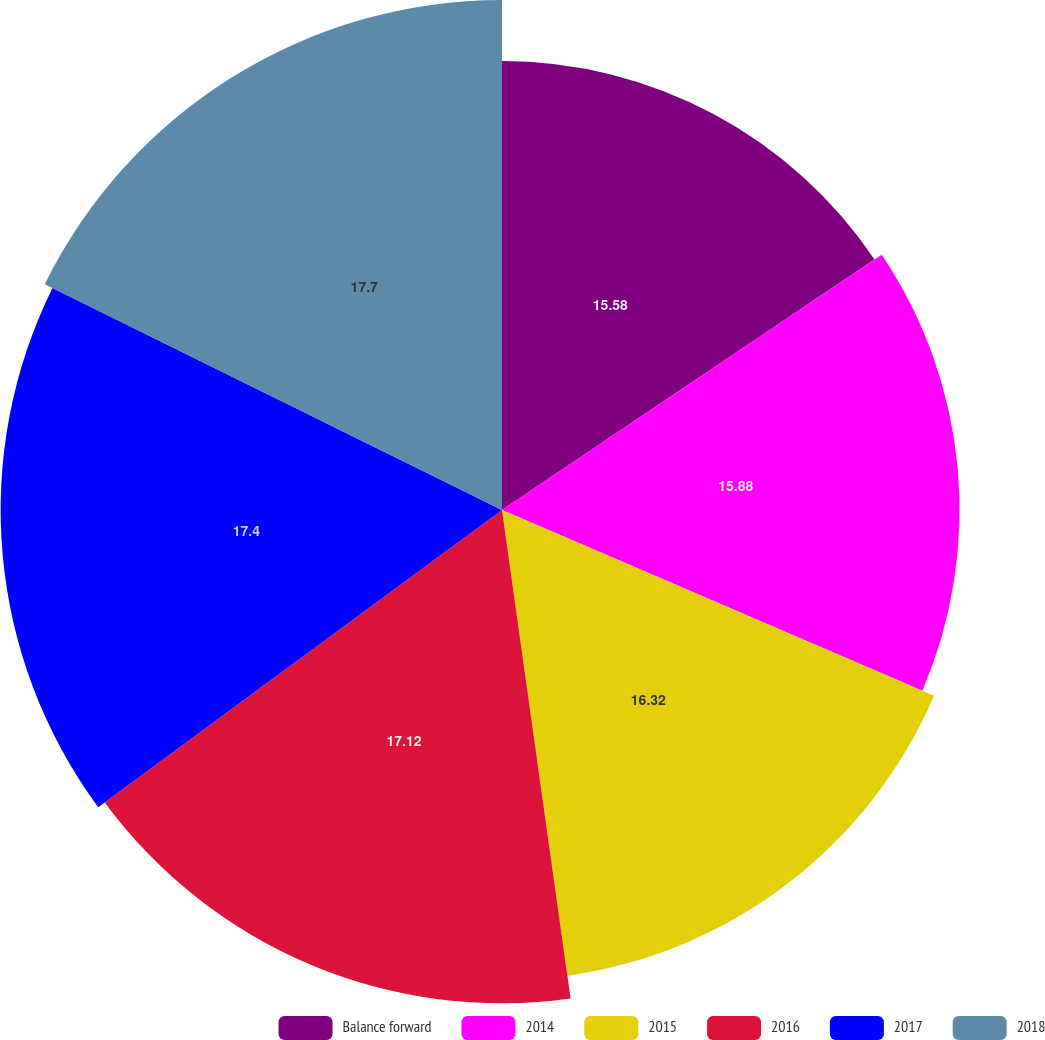<chart> <loc_0><loc_0><loc_500><loc_500><pie_chart><fcel>Balance forward<fcel>2014<fcel>2015<fcel>2016<fcel>2017<fcel>2018<nl><fcel>15.58%<fcel>15.88%<fcel>16.32%<fcel>17.12%<fcel>17.4%<fcel>17.7%<nl></chart> 